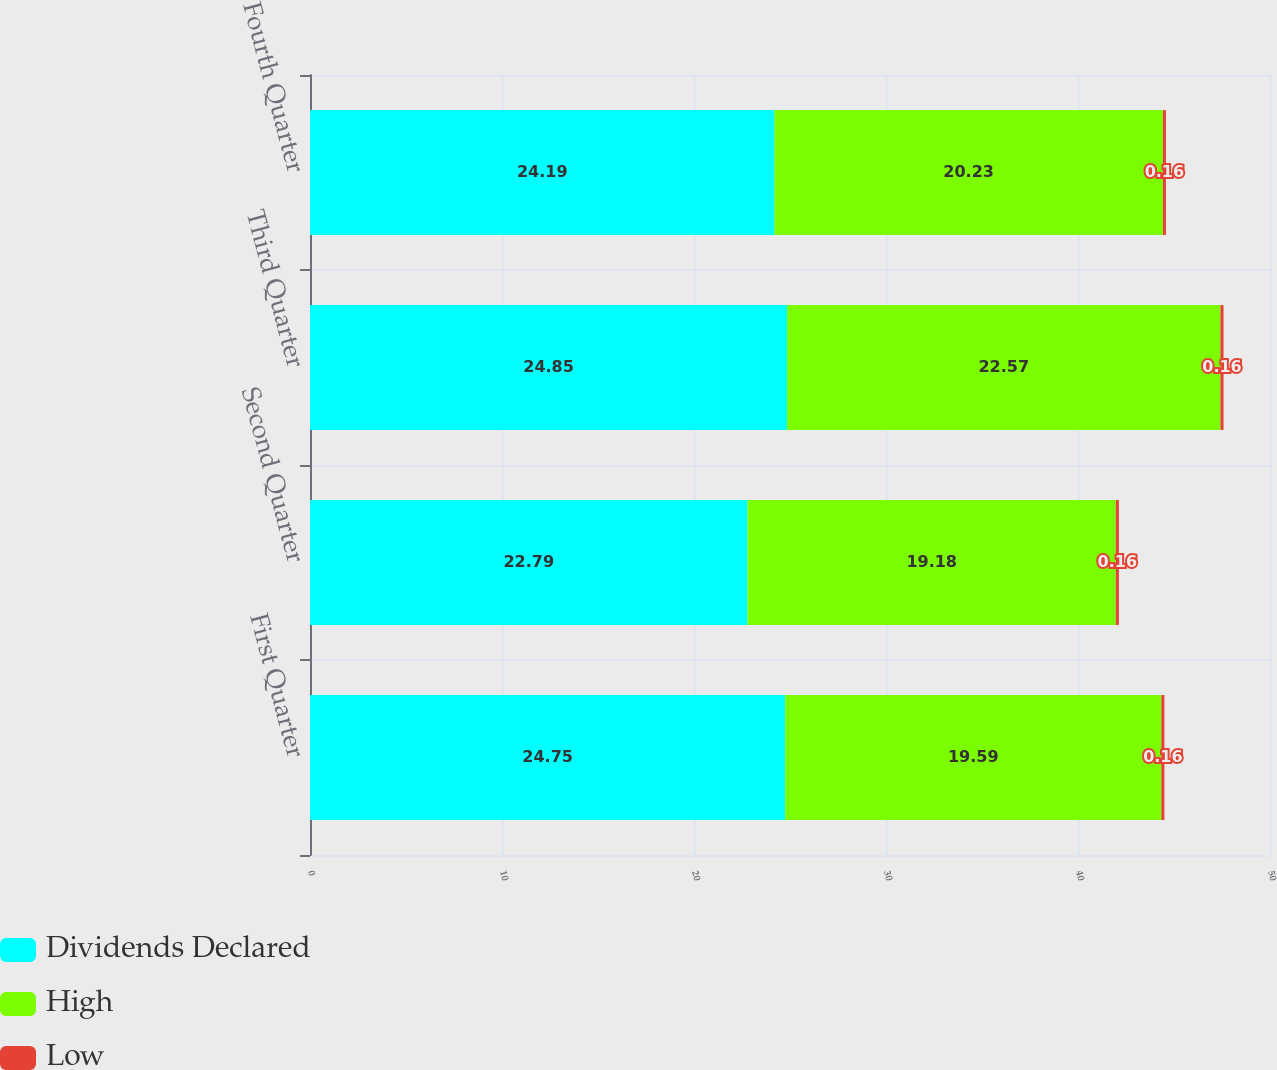<chart> <loc_0><loc_0><loc_500><loc_500><stacked_bar_chart><ecel><fcel>First Quarter<fcel>Second Quarter<fcel>Third Quarter<fcel>Fourth Quarter<nl><fcel>Dividends Declared<fcel>24.75<fcel>22.79<fcel>24.85<fcel>24.19<nl><fcel>High<fcel>19.59<fcel>19.18<fcel>22.57<fcel>20.23<nl><fcel>Low<fcel>0.16<fcel>0.16<fcel>0.16<fcel>0.16<nl></chart> 